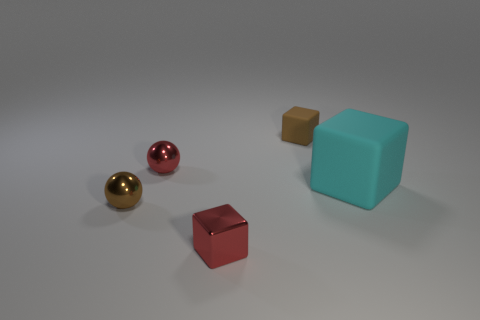Add 1 tiny yellow cubes. How many objects exist? 6 Subtract all spheres. How many objects are left? 3 Add 3 big blocks. How many big blocks are left? 4 Add 1 large cyan rubber blocks. How many large cyan rubber blocks exist? 2 Subtract 0 purple cylinders. How many objects are left? 5 Subtract all big rubber cubes. Subtract all matte blocks. How many objects are left? 2 